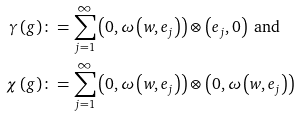<formula> <loc_0><loc_0><loc_500><loc_500>\gamma \left ( g \right ) & \colon = \sum _ { j = 1 } ^ { \infty } \left ( 0 , \omega \left ( w , e _ { j } \right ) \right ) \otimes \left ( e _ { j } , 0 \right ) \text { and} \\ \chi \left ( g \right ) & \colon = \sum _ { j = 1 } ^ { \infty } \left ( 0 , \omega \left ( w , e _ { j } \right ) \right ) \otimes \left ( 0 , \omega \left ( w , e _ { j } \right ) \right )</formula> 